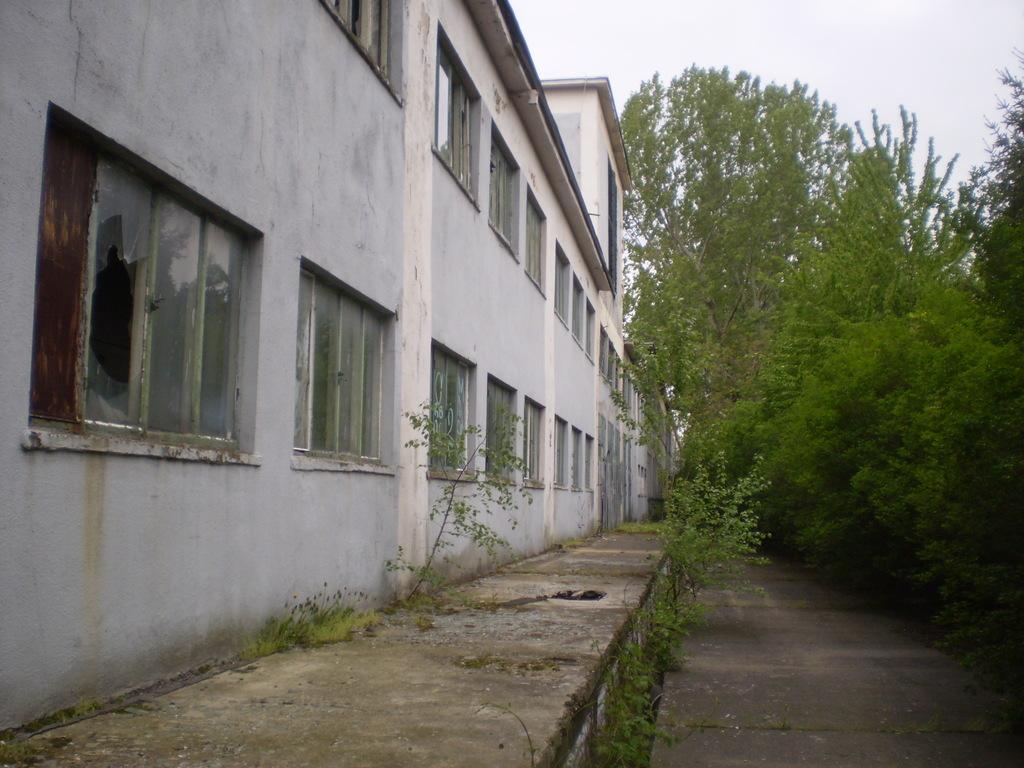Please provide a concise description of this image. This image is taken outdoors. At the top of the image there is a sky with clouds. On the right side of the image there are a few trees and plants. On the left side of the image there is a building with walls, windows, a door and a roof. At the bottom of the image there is a road and there is a sidewalk. 